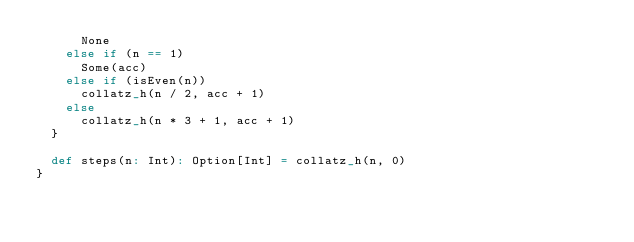Convert code to text. <code><loc_0><loc_0><loc_500><loc_500><_Scala_>      None
    else if (n == 1)
      Some(acc)
    else if (isEven(n))
      collatz_h(n / 2, acc + 1)
    else
      collatz_h(n * 3 + 1, acc + 1)
  }

  def steps(n: Int): Option[Int] = collatz_h(n, 0)
}
</code> 